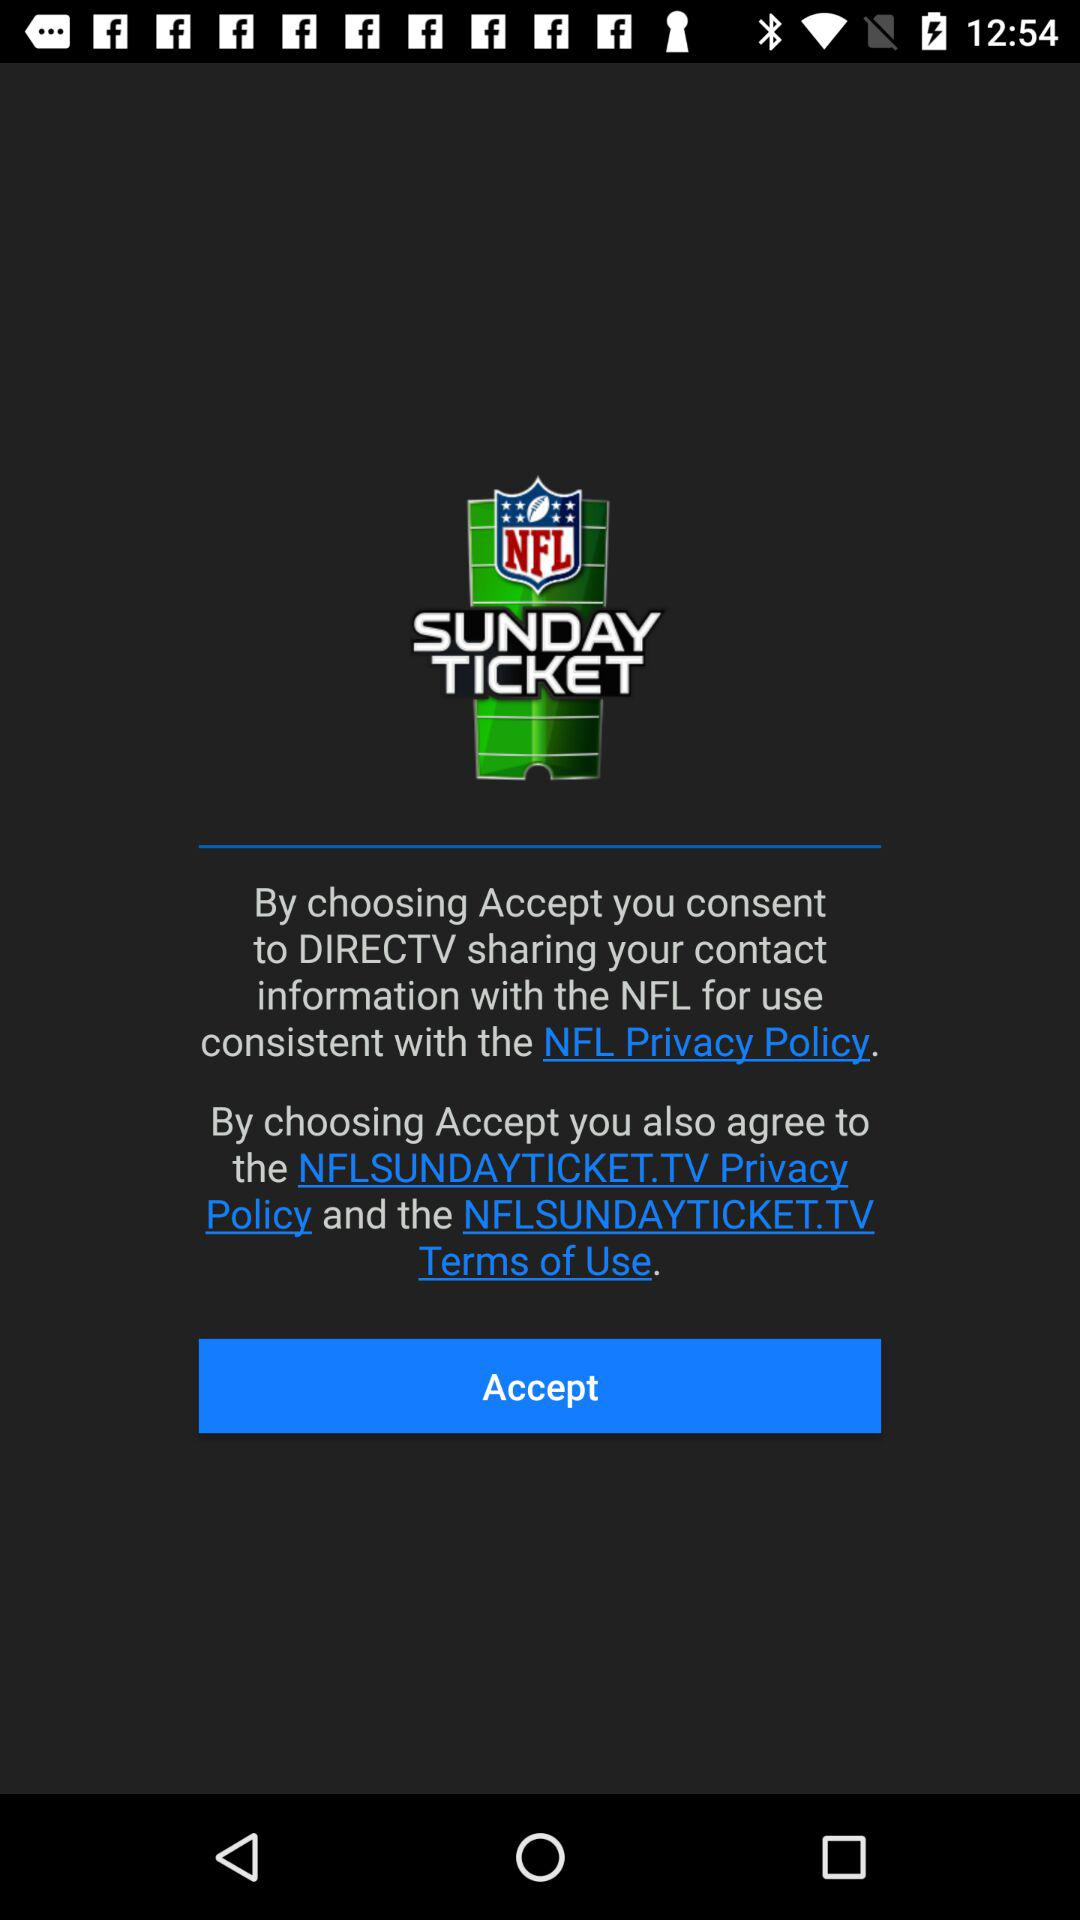Has the user agreed to the terms of service and privacy policy?
When the provided information is insufficient, respond with <no answer>. <no answer> 